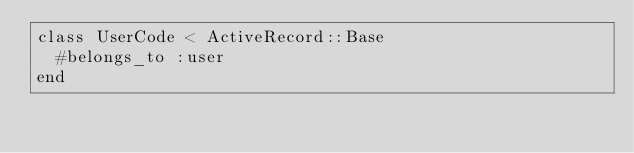Convert code to text. <code><loc_0><loc_0><loc_500><loc_500><_Ruby_>class UserCode < ActiveRecord::Base
  #belongs_to :user
end
</code> 